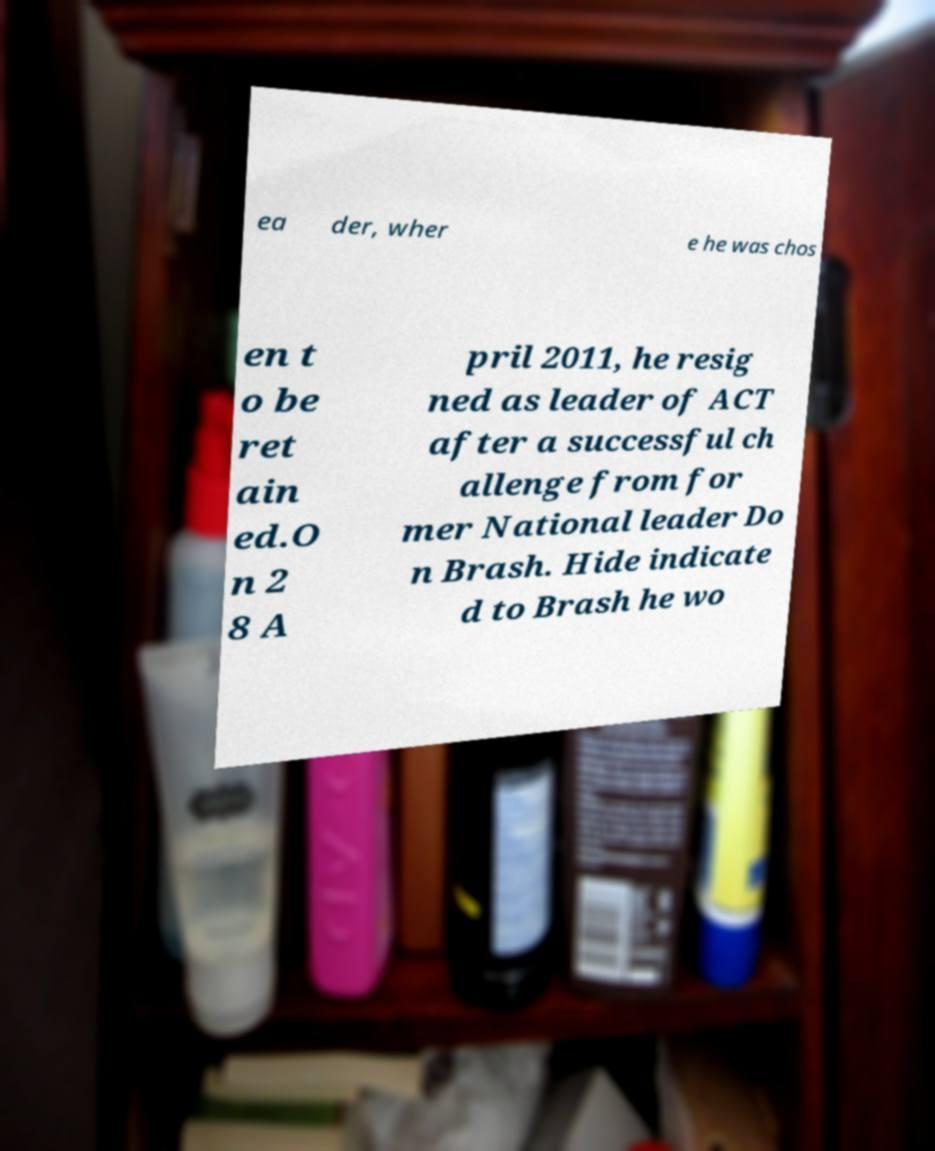Can you accurately transcribe the text from the provided image for me? ea der, wher e he was chos en t o be ret ain ed.O n 2 8 A pril 2011, he resig ned as leader of ACT after a successful ch allenge from for mer National leader Do n Brash. Hide indicate d to Brash he wo 